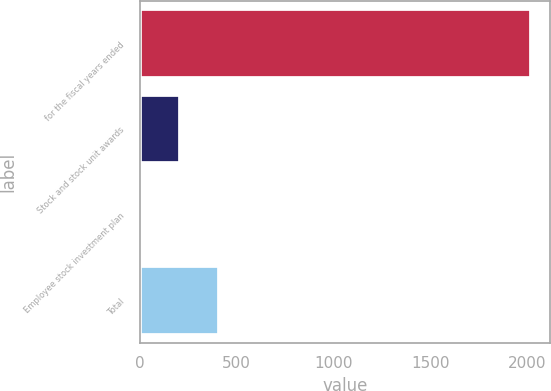Convert chart. <chart><loc_0><loc_0><loc_500><loc_500><bar_chart><fcel>for the fiscal years ended<fcel>Stock and stock unit awards<fcel>Employee stock investment plan<fcel>Total<nl><fcel>2018<fcel>207.38<fcel>6.2<fcel>408.56<nl></chart> 